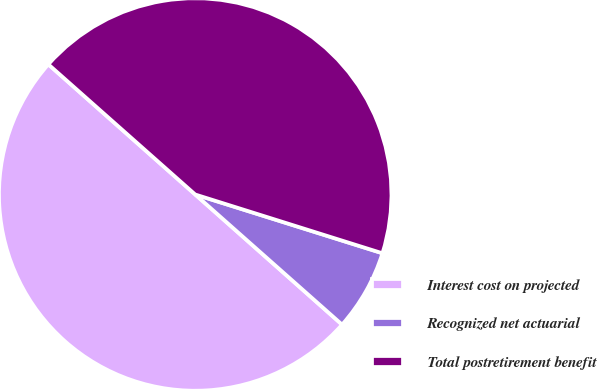<chart> <loc_0><loc_0><loc_500><loc_500><pie_chart><fcel>Interest cost on projected<fcel>Recognized net actuarial<fcel>Total postretirement benefit<nl><fcel>50.0%<fcel>6.7%<fcel>43.3%<nl></chart> 